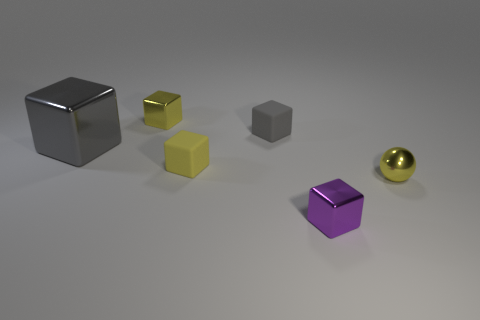What number of other objects are there of the same size as the purple thing?
Ensure brevity in your answer.  4. What is the color of the metallic cube to the right of the tiny rubber object behind the gray thing on the left side of the yellow metallic block?
Make the answer very short. Purple. What number of small yellow metal blocks are in front of the yellow metal object that is on the right side of the tiny shiny cube behind the tiny yellow shiny ball?
Provide a short and direct response. 0. Is there anything else that is the same color as the large thing?
Keep it short and to the point. Yes. There is a matte object that is in front of the gray shiny cube; does it have the same size as the purple block?
Your response must be concise. Yes. What number of rubber cubes are behind the small metal object to the right of the small purple cube?
Make the answer very short. 2. Is there a large gray block that is to the left of the block that is in front of the yellow object that is right of the yellow rubber block?
Keep it short and to the point. Yes. There is a small gray object that is the same shape as the big gray metal thing; what is its material?
Your answer should be compact. Rubber. Are the tiny purple object and the tiny yellow block that is in front of the big cube made of the same material?
Your answer should be very brief. No. There is a small shiny thing to the right of the tiny shiny object that is in front of the metallic sphere; what is its shape?
Make the answer very short. Sphere. 